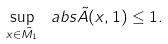<formula> <loc_0><loc_0><loc_500><loc_500>\sup _ { x \in \tilde { M _ { 1 } } } \ a b s { \tilde { A } ( x , 1 ) } \leq 1 .</formula> 